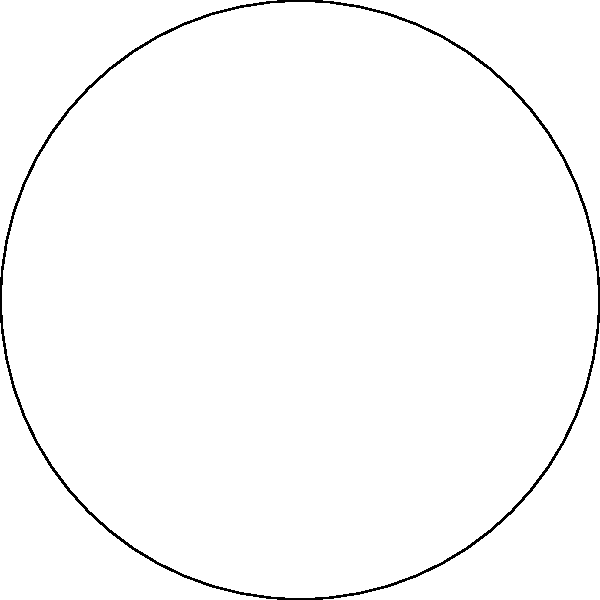In your bicycle shop, you're explaining to a customer how wheel alignment principles relate to non-Euclidean geometry. Using the spherical surface shown above, calculate the sum of the interior angles of triangle ABC. How does this result differ from a flat plane, and what implications might this have for bicycle wheel alignment on curved surfaces? To understand this problem, let's break it down step-by-step:

1) In Euclidean geometry (flat plane), the sum of interior angles of a triangle is always 180°.

2) On a sphere, however, we're dealing with spherical geometry, which is non-Euclidean. In spherical geometry, the sum of interior angles of a triangle is always greater than 180°.

3) For a spherical triangle, the sum of interior angles is given by the formula:

   $$\text{Sum of angles} = 180° + A$$

   where $A$ is the area of the triangle on the unit sphere (in steradians).

4) The excess angle (amount over 180°) is directly proportional to the area of the triangle on the sphere's surface.

5) In the extreme case, if the triangle covers 1/8th of the sphere's surface, its angles would each be 90°, summing to 270°.

6) For bicycle wheel alignment, this means that on curved surfaces (like banked tracks or uneven terrain), the typical flat-surface alignment principles might need adjustment.

7) The larger the curved surface (relative to the bicycle), the more significant this effect becomes. For most road surfaces, the effect is negligible, but for specialized cycling tracks or mountain biking, it could be a consideration.

8) In practical terms, this might mean that wheels aligned perfectly on a flat surface might experience slight misalignment or uneven wear when consistently used on curved surfaces.
Answer: $>180°$; curved surfaces may require adjusted alignment techniques. 